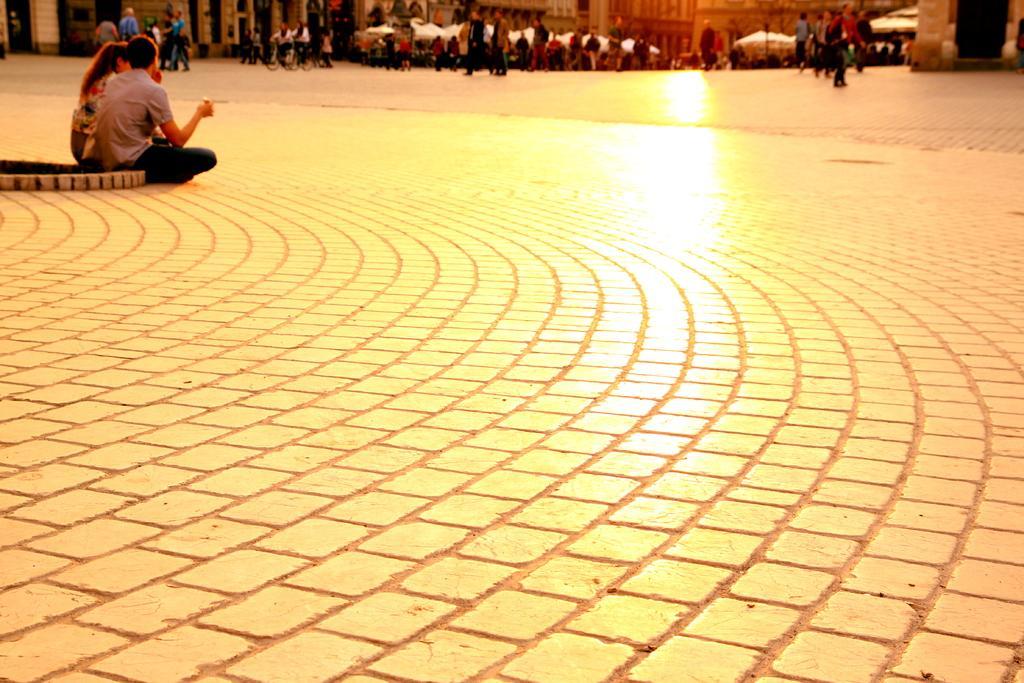In one or two sentences, can you explain what this image depicts? In this image, we can see a walkway. Top of the image, we can see a group of people. Few are sitting , standing and walking. Here we can see buildings and trees. 